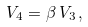Convert formula to latex. <formula><loc_0><loc_0><loc_500><loc_500>V _ { 4 } = \beta \, V _ { 3 } \, ,</formula> 